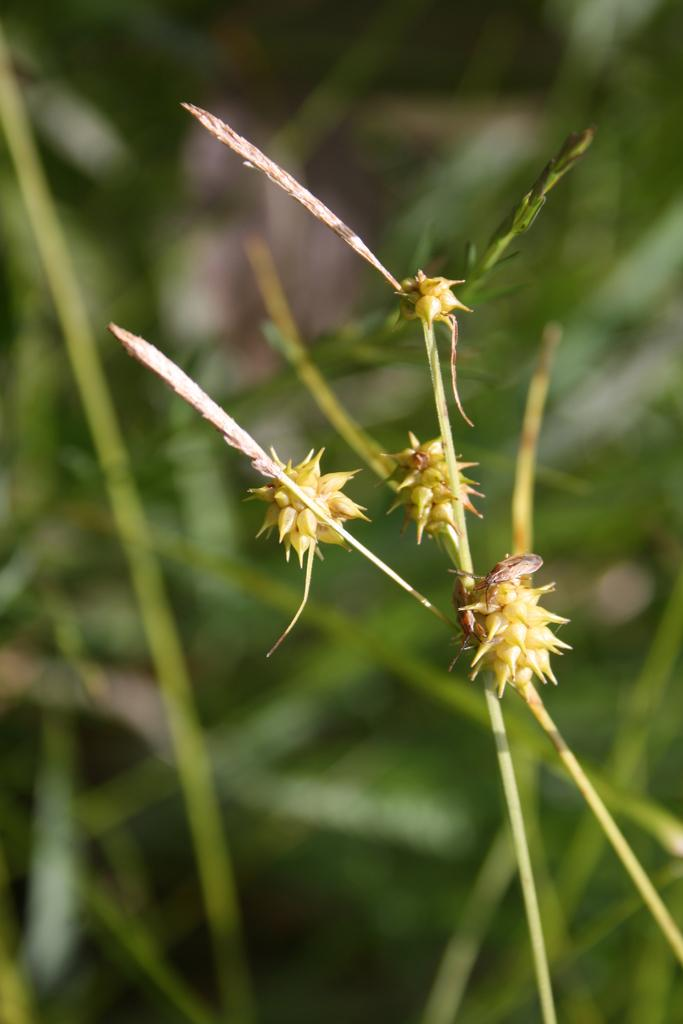What type of creature can be seen in the image? There is an insect in the image. Where is the insect located? The insect is on a plant. What can be observed about the background of the image? The background of the image is blurred. What type of vegetation is visible in the background? There is greenery in the background of the image. What selection of statements does the insect's aunt make in the image? There is no mention of an aunt or any statements in the image; it features an insect on a plant with a blurred background and greenery. 